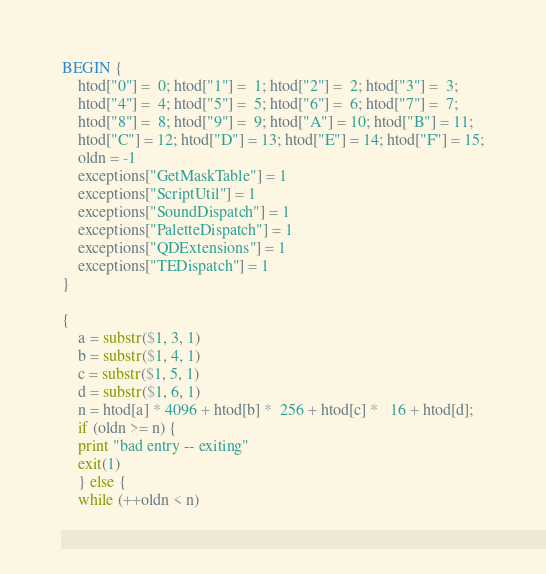<code> <loc_0><loc_0><loc_500><loc_500><_Awk_>BEGIN {
    htod["0"] =  0; htod["1"] =  1; htod["2"] =  2; htod["3"] =  3;
    htod["4"] =  4; htod["5"] =  5; htod["6"] =  6; htod["7"] =  7;
    htod["8"] =  8; htod["9"] =  9; htod["A"] = 10; htod["B"] = 11;
    htod["C"] = 12; htod["D"] = 13; htod["E"] = 14; htod["F"] = 15;
    oldn = -1
    exceptions["GetMaskTable"] = 1
    exceptions["ScriptUtil"] = 1
    exceptions["SoundDispatch"] = 1
    exceptions["PaletteDispatch"] = 1
    exceptions["QDExtensions"] = 1
    exceptions["TEDispatch"] = 1
}

{
    a = substr($1, 3, 1)
    b = substr($1, 4, 1)
    c = substr($1, 5, 1)
    d = substr($1, 6, 1)
    n = htod[a] * 4096 + htod[b] *  256 + htod[c] *   16 + htod[d];
    if (oldn >= n) {
	print "bad entry -- exiting"
	exit(1)
    } else {
	while (++oldn < n)</code> 